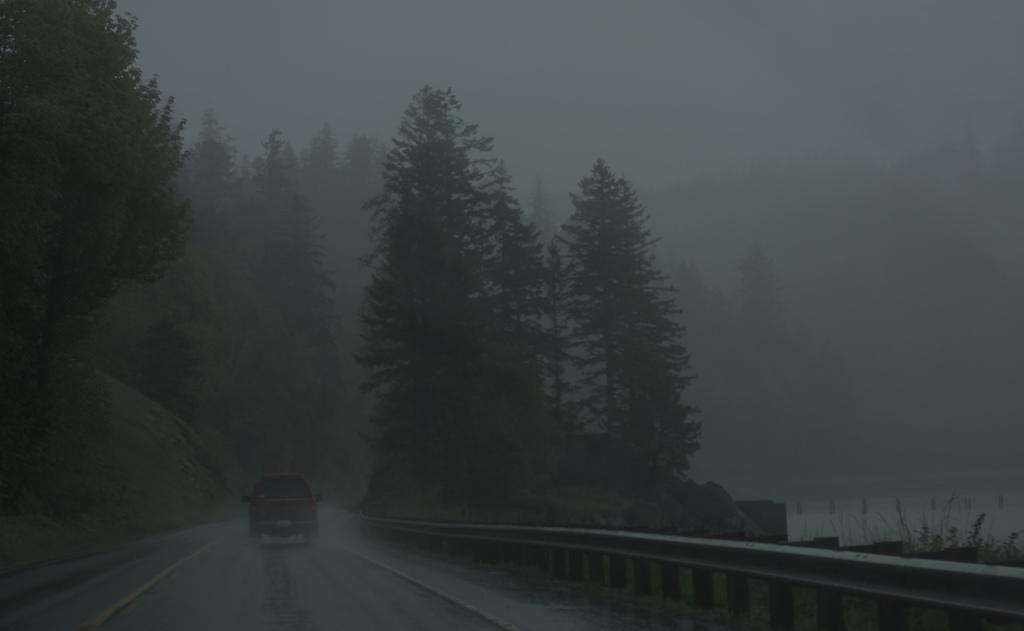Can you describe this image briefly? There are trees, there is car on the road, this is sky. 